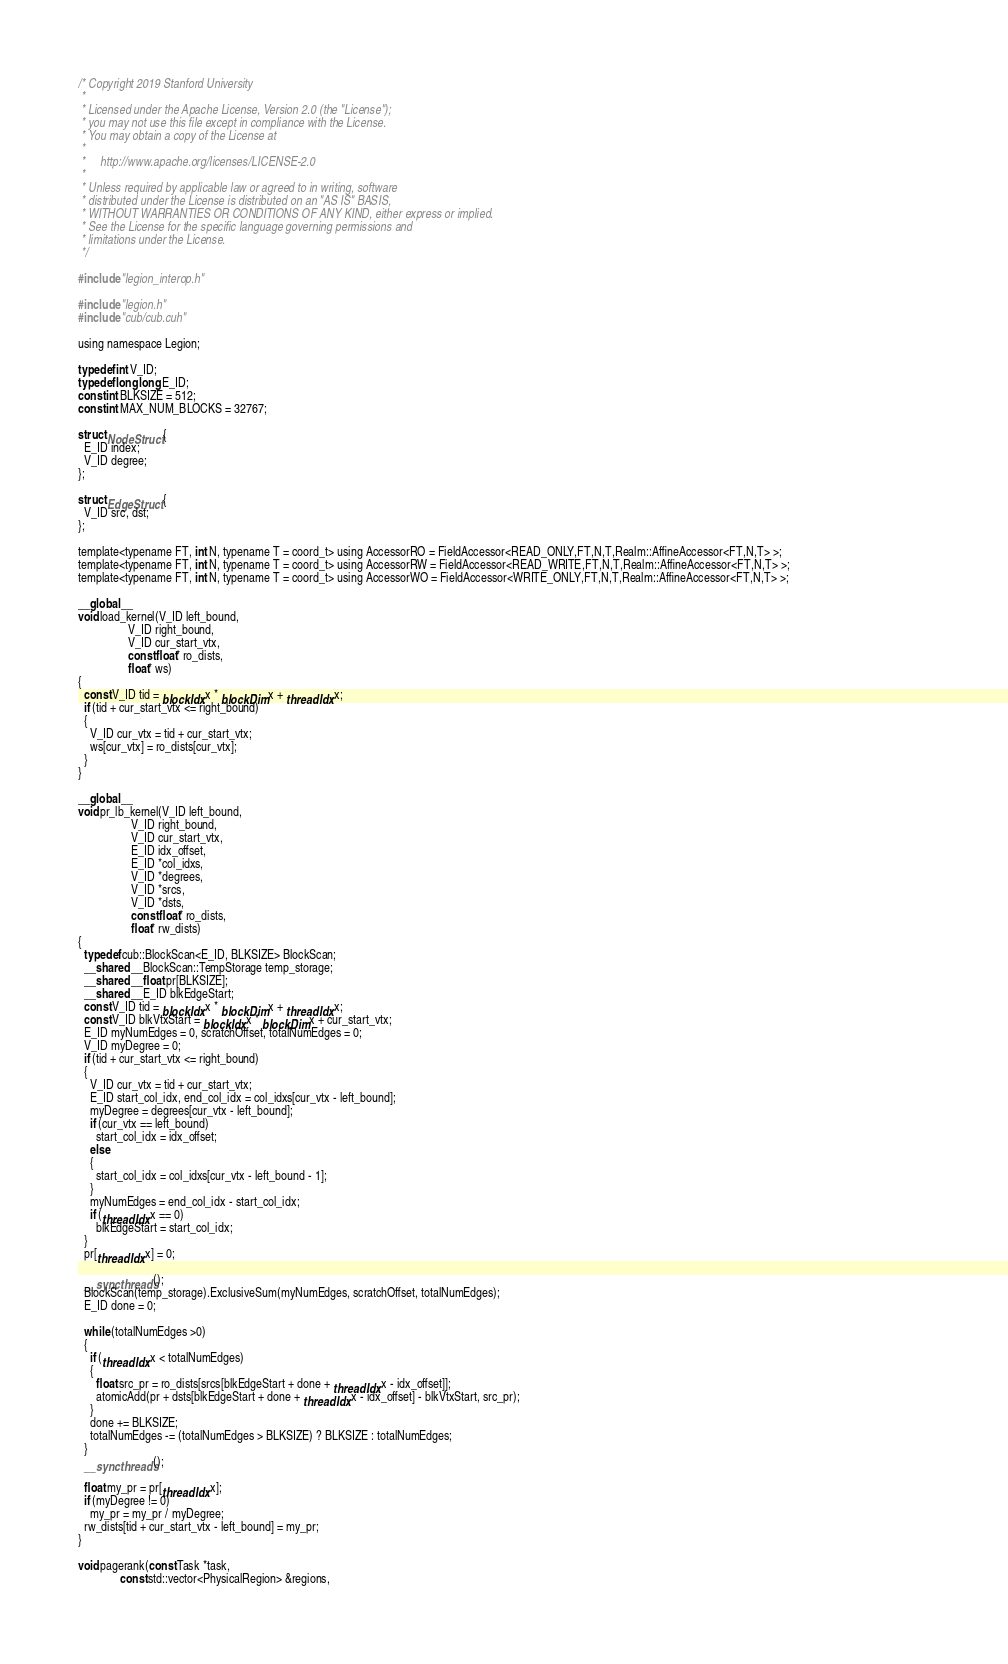<code> <loc_0><loc_0><loc_500><loc_500><_Cuda_>/* Copyright 2019 Stanford University
 *
 * Licensed under the Apache License, Version 2.0 (the "License");
 * you may not use this file except in compliance with the License.
 * You may obtain a copy of the License at
 *
 *     http://www.apache.org/licenses/LICENSE-2.0
 *
 * Unless required by applicable law or agreed to in writing, software
 * distributed under the License is distributed on an "AS IS" BASIS,
 * WITHOUT WARRANTIES OR CONDITIONS OF ANY KIND, either express or implied.
 * See the License for the specific language governing permissions and
 * limitations under the License.
 */

#include "legion_interop.h"

#include "legion.h"
#include "cub/cub.cuh"

using namespace Legion;

typedef int V_ID;
typedef long long E_ID;
const int BLKSIZE = 512;
const int MAX_NUM_BLOCKS = 32767;

struct NodeStruct {
  E_ID index;
  V_ID degree;
};

struct EdgeStruct {
  V_ID src, dst;
};

template<typename FT, int N, typename T = coord_t> using AccessorRO = FieldAccessor<READ_ONLY,FT,N,T,Realm::AffineAccessor<FT,N,T> >;                                                
template<typename FT, int N, typename T = coord_t> using AccessorRW = FieldAccessor<READ_WRITE,FT,N,T,Realm::AffineAccessor<FT,N,T> >;                                               
template<typename FT, int N, typename T = coord_t> using AccessorWO = FieldAccessor<WRITE_ONLY,FT,N,T,Realm::AffineAccessor<FT,N,T> >; 

__global__
void load_kernel(V_ID left_bound,
                 V_ID right_bound,
                 V_ID cur_start_vtx,
                 const float* ro_dists,
                 float* ws)
{
  const V_ID tid = blockIdx.x * blockDim.x + threadIdx.x;
  if (tid + cur_start_vtx <= right_bound)
  {
    V_ID cur_vtx = tid + cur_start_vtx;
    ws[cur_vtx] = ro_dists[cur_vtx];
  }
}

__global__
void pr_lb_kernel(V_ID left_bound,
                  V_ID right_bound,
                  V_ID cur_start_vtx,
                  E_ID idx_offset,
                  E_ID *col_idxs,
                  V_ID *degrees,
                  V_ID *srcs,
                  V_ID *dsts,
                  const float* ro_dists,
                  float* rw_dists)
{
  typedef cub::BlockScan<E_ID, BLKSIZE> BlockScan;
  __shared__ BlockScan::TempStorage temp_storage;
  __shared__ float pr[BLKSIZE];
  __shared__ E_ID blkEdgeStart;
  const V_ID tid = blockIdx.x * blockDim.x + threadIdx.x;
  const V_ID blkVtxStart = blockIdx.x * blockDim.x + cur_start_vtx;
  E_ID myNumEdges = 0, scratchOffset, totalNumEdges = 0;
  V_ID myDegree = 0;
  if (tid + cur_start_vtx <= right_bound)
  {
    V_ID cur_vtx = tid + cur_start_vtx;
    E_ID start_col_idx, end_col_idx = col_idxs[cur_vtx - left_bound];
    myDegree = degrees[cur_vtx - left_bound];
    if (cur_vtx == left_bound)
      start_col_idx = idx_offset;
    else
    {
      start_col_idx = col_idxs[cur_vtx - left_bound - 1];
    }
    myNumEdges = end_col_idx - start_col_idx;
    if (threadIdx.x == 0)
      blkEdgeStart = start_col_idx;
  }
  pr[threadIdx.x] = 0;

  __syncthreads();
  BlockScan(temp_storage).ExclusiveSum(myNumEdges, scratchOffset, totalNumEdges);
  E_ID done = 0;

  while (totalNumEdges >0)
  {
    if (threadIdx.x < totalNumEdges)
    {
      float src_pr = ro_dists[srcs[blkEdgeStart + done + threadIdx.x - idx_offset]];
      atomicAdd(pr + dsts[blkEdgeStart + done + threadIdx.x - idx_offset] - blkVtxStart, src_pr);
    }
    done += BLKSIZE;
    totalNumEdges -= (totalNumEdges > BLKSIZE) ? BLKSIZE : totalNumEdges;
  }
  __syncthreads();

  float my_pr = pr[threadIdx.x];
  if (myDegree != 0)
    my_pr = my_pr / myDegree;
  rw_dists[tid + cur_start_vtx - left_bound] = my_pr;
}

void pagerank(const Task *task,
              const std::vector<PhysicalRegion> &regions,</code> 